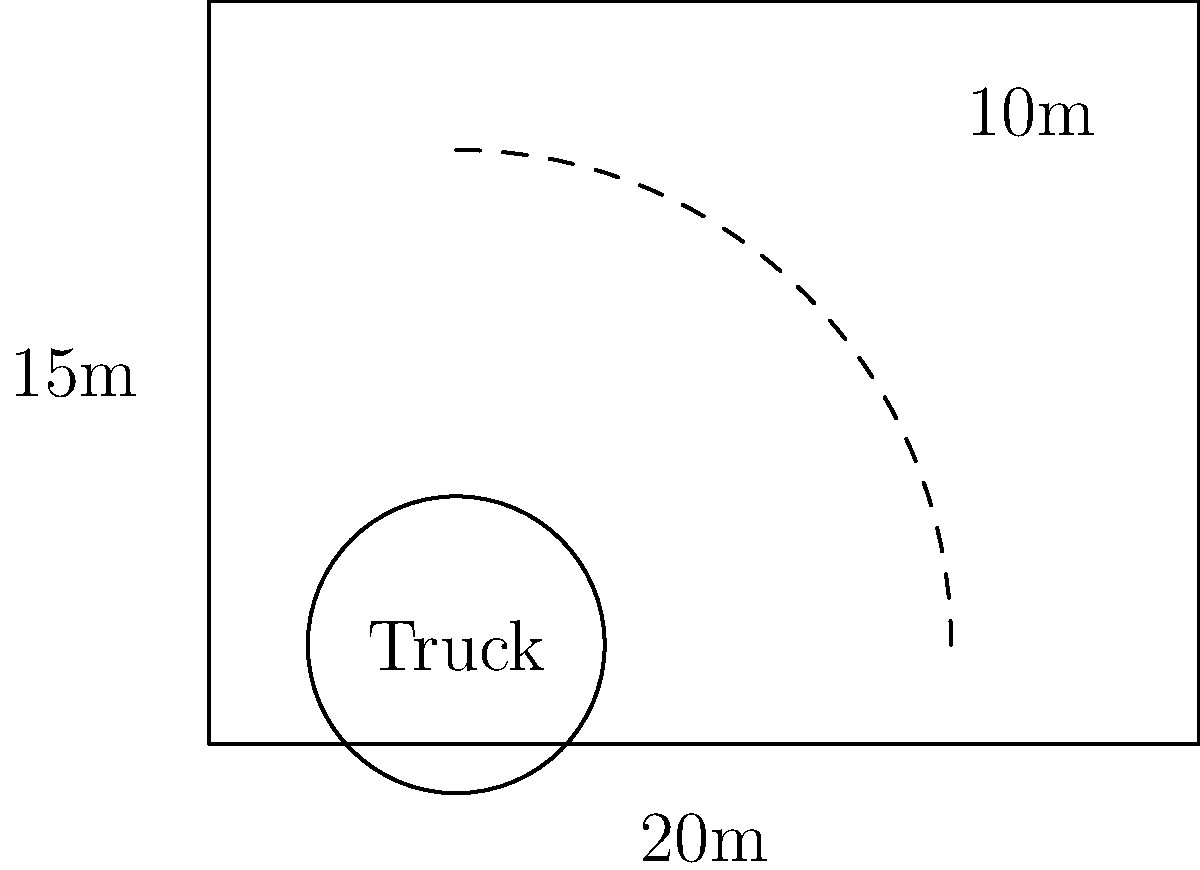A liquor store is designing a new loading zone for delivery trucks carrying bourbon from your distillery. The loading zone is rectangular with dimensions of 20m x 15m. If the minimum turning radius for the delivery trucks is 10m, what is the maximum width of the trucks that can safely maneuver within this loading zone? To solve this problem, we need to consider the geometry of the loading zone and the turning radius of the trucks. Let's approach this step-by-step:

1. The loading zone dimensions are 20m x 15m.
2. The minimum turning radius of the trucks is 10m.

3. For a truck to make a 90-degree turn within the loading zone, we need to ensure there's enough space for the turning circle.

4. The turning circle will be tangent to two adjacent sides of the loading zone.

5. The radius of this turning circle is the minimum turning radius, which is 10m.

6. The center of this turning circle will be located 10m from each of these two adjacent sides.

7. This leaves a space of 5m on the width (15m - 10m = 5m) and 10m on the length (20m - 10m = 10m).

8. The truck needs to fit within this remaining space.

9. The limiting factor is the smaller dimension, which is the 5m width.

10. However, we need to account for some clearance for safety and maneuvering. A standard clearance is about 0.5m on each side.

11. Therefore, the maximum width of the truck would be:
   $5m - (2 * 0.5m) = 4m$

Thus, the maximum width of the trucks that can safely maneuver within this loading zone is 4m.
Answer: 4m 